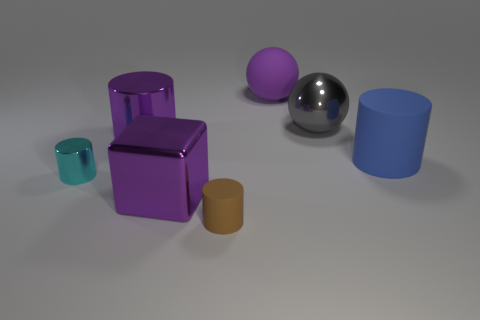Subtract 1 cylinders. How many cylinders are left? 3 Subtract all yellow cylinders. Subtract all cyan blocks. How many cylinders are left? 4 Add 2 big blue objects. How many objects exist? 9 Subtract all cylinders. How many objects are left? 3 Add 6 small gray rubber blocks. How many small gray rubber blocks exist? 6 Subtract 0 cyan spheres. How many objects are left? 7 Subtract all large green matte balls. Subtract all purple blocks. How many objects are left? 6 Add 2 big gray shiny balls. How many big gray shiny balls are left? 3 